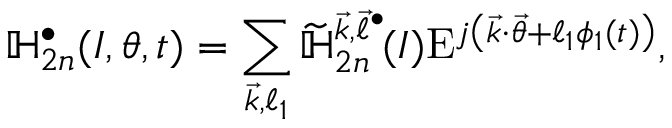Convert formula to latex. <formula><loc_0><loc_0><loc_500><loc_500>\mathbb { H } _ { 2 n } ^ { \bullet } ( I , \theta , t ) = \sum _ { \substack { \vec { k } , \ell _ { 1 } } } \widetilde { \mathbb { H } } _ { 2 n } ^ { \vec { k } , \vec { \ell } ^ { \bullet } } \, ( I ) E ^ { j \left ( \vec { k } \cdot \vec { \theta } + \ell _ { 1 } \phi _ { 1 } ( t ) \right ) } ,</formula> 